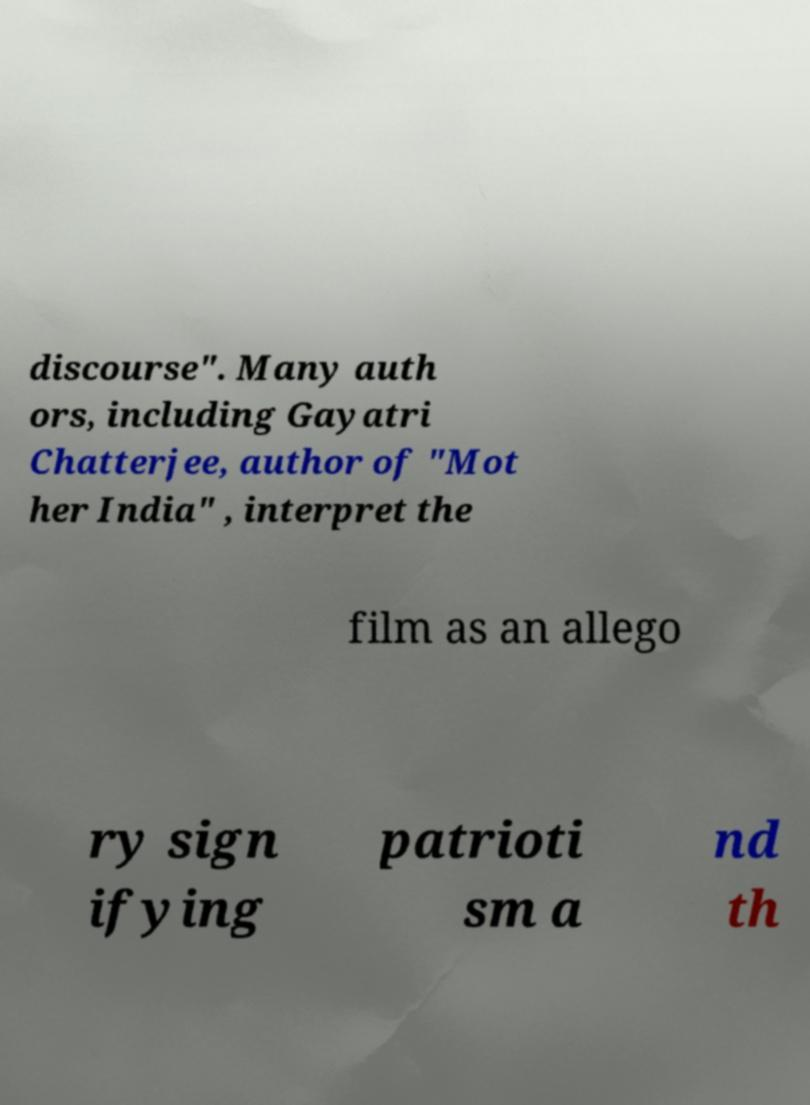I need the written content from this picture converted into text. Can you do that? discourse". Many auth ors, including Gayatri Chatterjee, author of "Mot her India" , interpret the film as an allego ry sign ifying patrioti sm a nd th 